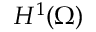<formula> <loc_0><loc_0><loc_500><loc_500>H ^ { 1 } ( \Omega )</formula> 